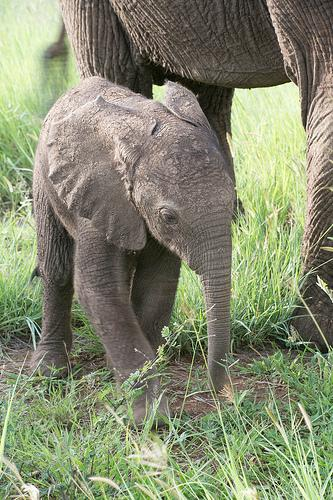Provide a descriptive caption for this image. A young baby elephant standing near its mother in a field of green grass and patches of brown dirt, with long green grass growing behind them. Assess the image's quality and sentiment based on the content. The image quality is detailed with high accuracy, depicting a positive sentiment with a young elephant in a natural environment. What is the primary object in this image? A young elephant. What complex reasoning can be inferred from the image? The baby elephant is learning to navigate its environment with its mother's guidance in a relatively natural habitat. What are the physical characteristics of the young elephant? Gray skin, black eye, long trunk, and four legs. Enumerate the visible elements in the scene. Young elephant, adult elephant's leg, green grass, brown dirt, patches of barren land, black eye, grey skin, trunk, and tail. What type of environment are the elephants in, and what color is the grass? The elephants are in a field with patches of green grass and brown dirt. How many elephants are visible, and what interaction is happening between them? Two elephants, with the young elephant standing near its mother. Identify the animal and its related body parts located in the picture. Elephant - trunk, leg, tail, black eye, and grey skin. Count the number of primary objects in the image and describe them. Three primary objects: young elephant, part of an adult elephant's leg, and the field with green grass and brown dirt. Have you noticed the orange butterfly gently resting on the baby elephant's trunk? It's such a peaceful and delicate sight, symbolizing harmony between species. No, it's not mentioned in the image. 